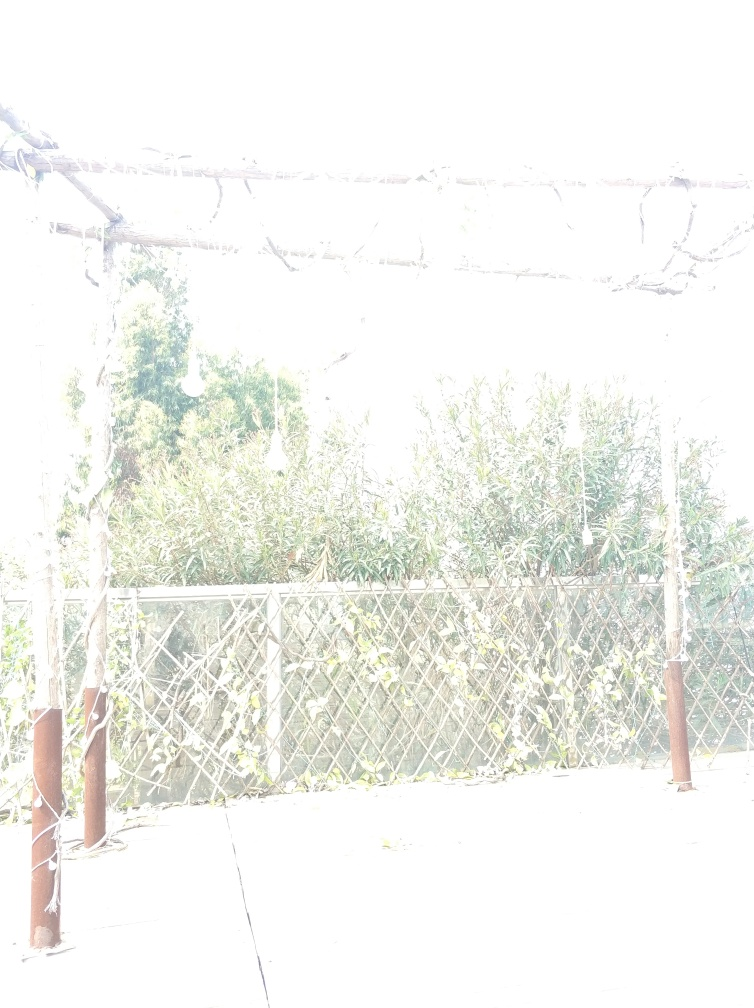Is the overall sharpness of the image good? The image is significantly overexposed, which has compromised the details and sharpness in most areas. Overexposure occurs when too much light is allowed to enter the camera during the photo-taking process, which results in a loss of detail and a predominance of bright areas, as seen here. In this state, the sharpness cannot be accurately assessed since the details are washed out. 